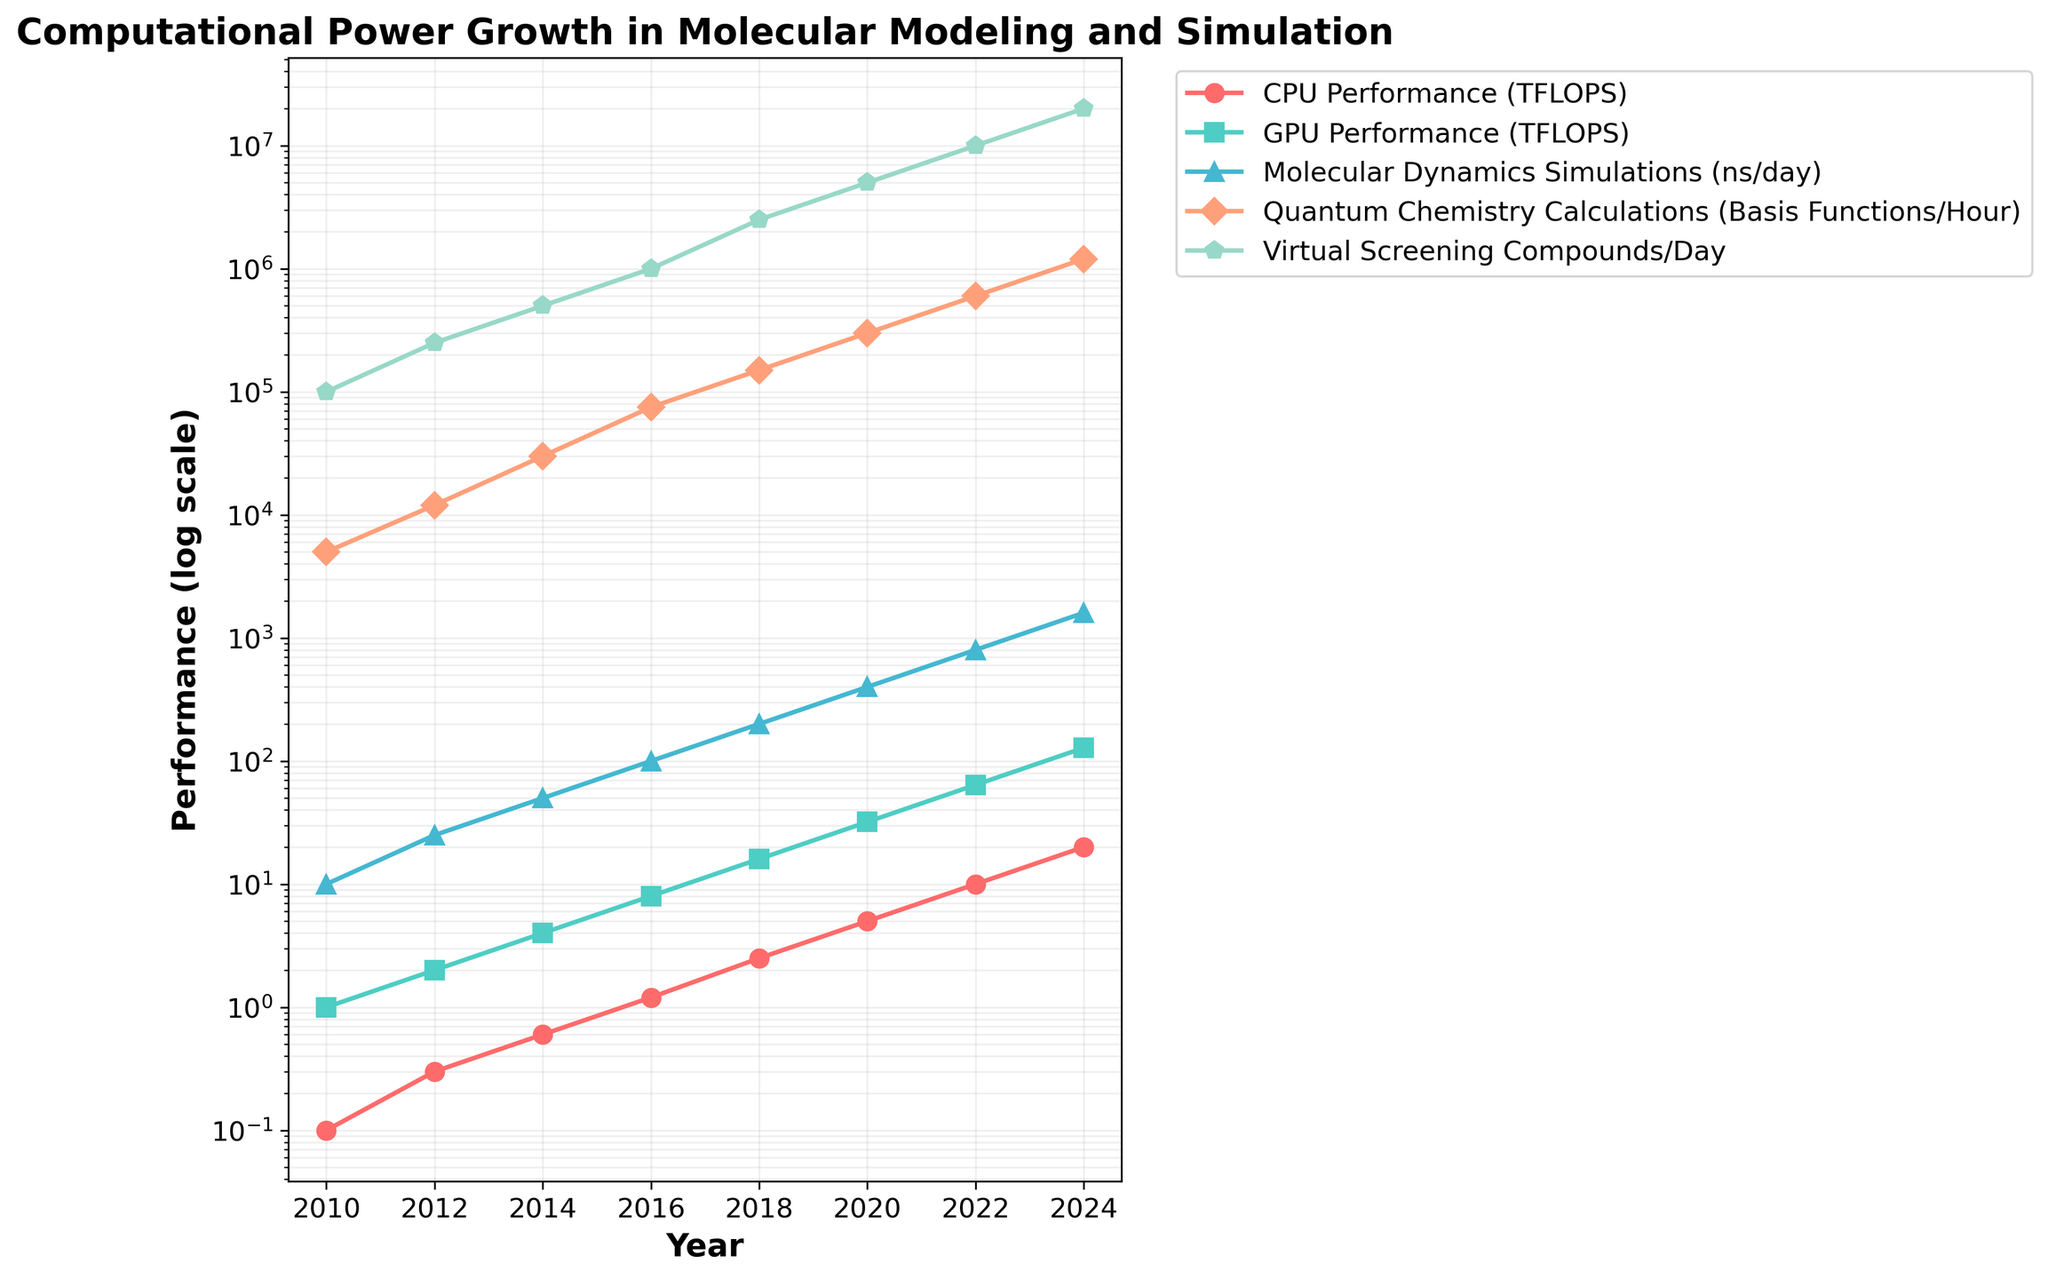Which year saw the greatest increase in GPU performance? To determine the year with the greatest increase in GPU performance, we compare the change in values between consecutive years. The differences are 1 (2010-2012), 2 (2012-2014), 4 (2014-2016), 8 (2016-2018), 16 (2018-2020), 32 (2020-2022), and 64 (2022-2024). The largest increase, 64, occurs between 2022 and 2024.
Answer: 2024 How does the CPU performance in 2018 compare to GPU performance in 2010? First, identify the CPU performance in 2018 (2.5 TFLOPS) and GPU performance in 2010 (1 TFLOPS). CPU performance in 2018 is higher than GPU performance in 2010 by comparing 2.5 > 1.
Answer: Higher What is the trend in molecular dynamics simulations performance from 2012 to 2022? The molecular dynamics simulations performance in 2012 is 25 ns/day, and it increases progressively to 1600 ns/day in 2022. By analyzing the yearly data points, the trend shows a consistent and exponential rise over the decade.
Answer: Exponential increase Determine the rate of change in quantum chemistry calculations from 2016 to 2020. Quantum chemistry calculations performance in 2016 is 75,000 basis functions/hour and in 2020 is 300,000 basis functions/hour. Calculate the rate of change: (300,000 - 75,000) / 4 years = 56,250 basis functions/hour per year.
Answer: 56,250 basis functions/hour per year Which performance metric shows the most consistent growth throughout the period? By visually comparing the trajectories on the plot, Virtual Screening Compounds/Day shows consistent exponential growth, doubling approximately every couple of years, whereas other metrics have more varied growth rates.
Answer: Virtual Screening Compounds/Day Compare the growth in CPU performance to GPU performance between 2010 and 2024. CPU performance grows from 0.1 to 20 TFLOPS (a 200x increase), while GPU performance grows from 1 to 128 TFLOPS (a 128x increase). Compute the factor increase for each, with 200x for CPU and 128x for GPU, concluding CPU growth has a higher factor.
Answer: CPU has higher growth In which year does molecular dynamics simulation performance exceed 1000 ns/day? Check the molecular dynamics simulations performance for each year. In 2022, it’s 800 ns/day, and in 2024 it’s 1600 ns/day. Thus, it exceeds 1000 ns/day in 2024.
Answer: 2024 What is the color associated with the Quantum Chemistry Calculations line on the plot? Providing visual accuracy, the color associated with Quantum Chemistry Calculations in the legend is shown to be green.
Answer: Green How does the performance of Virtual Screening Compounds/Day in 2024 compare to 2010? Virtual Screening Compounds/Day in 2010 is 100,000 and in 2024 is 20,000,000. The ratio is calculated as 20,000,000 / 100,000 = 200, indicating a 200-fold increase.
Answer: 200-fold increase 